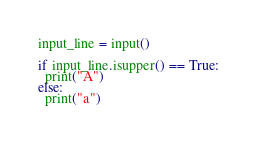Convert code to text. <code><loc_0><loc_0><loc_500><loc_500><_Python_>input_line = input()

if input_line.isupper() == True:
  print("A")
else:
  print("a")</code> 